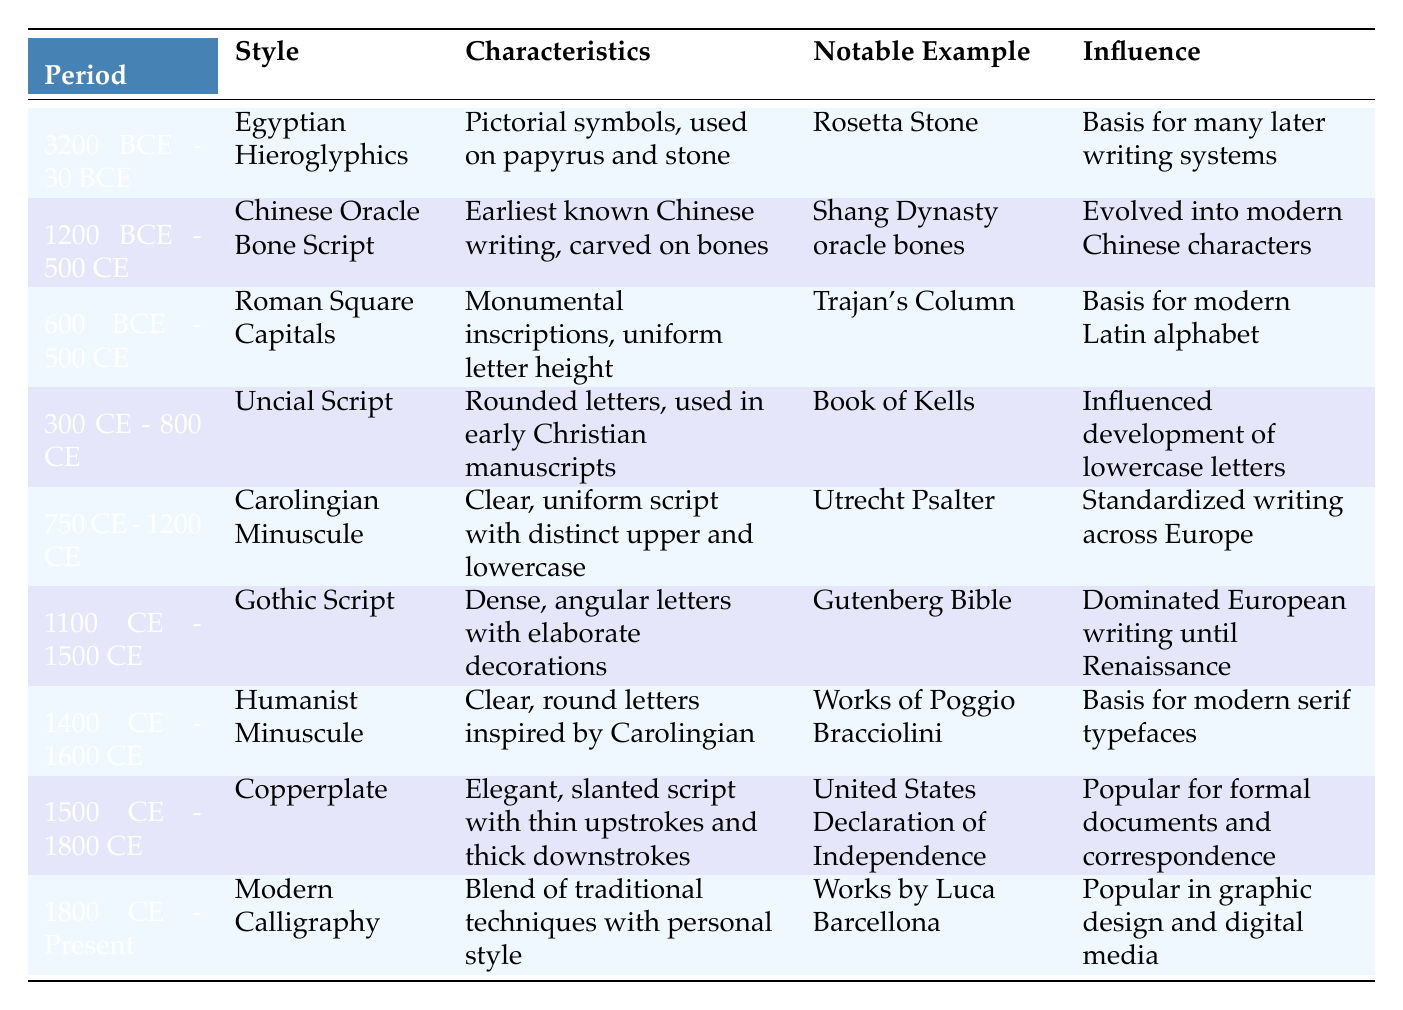What period corresponds to the Gothic Script? By looking at the table, we locate the row for Gothic Script, which shows its period as 1100 CE - 1500 CE.
Answer: 1100 CE - 1500 CE Which style evolved into modern Chinese characters? The table indicates that the Chinese Oracle Bone Script, listed in the period 1200 BCE - 500 CE, is noted for evolving into modern Chinese characters.
Answer: Chinese Oracle Bone Script Is the Trajan's Column associated with Uncial Script? The table lists Trajan's Column under Roman Square Capitals, not Uncial Script, so this statement is false.
Answer: No What are the characteristics of Copperplate? Referring to the row for Copperplate, it states the characteristics are "Elegant, slanted script with thin upstrokes and thick downstrokes."
Answer: Elegant, slanted script with thin upstrokes and thick downstrokes Which calligraphy style had a notable example of the Gutenberg Bible? Upon checking the table, the Gothic Script corresponds with the notable example of the Gutenberg Bible in the period of 1100 CE - 1500 CE.
Answer: Gothic Script What influence did Humanist Minuscule have for modern typefaces? The table shows that Humanist Minuscule is the basis for modern serif typefaces, indicating its significant impact on contemporary typography.
Answer: Basis for modern serif typefaces How many styles listed had a period starting before the year 1000 CE? By analyzing the periods in the table, we find that Egyptian Hieroglyphics, Chinese Oracle Bone Script, Roman Square Capitals, and Uncial Script all have periods starting before the year 1000 CE. This gives us a total of 4 styles.
Answer: 4 Which style was popular for formal documents and correspondence? The table specifies that Copperplate, with its elegant and formal characteristics, was popular for formal documents and correspondence.
Answer: Copperplate What is the notable example associated with Modern Calligraphy? The table states that the works by Luca Barcellona serve as the notable example for Modern Calligraphy.
Answer: Works by Luca Barcellona 